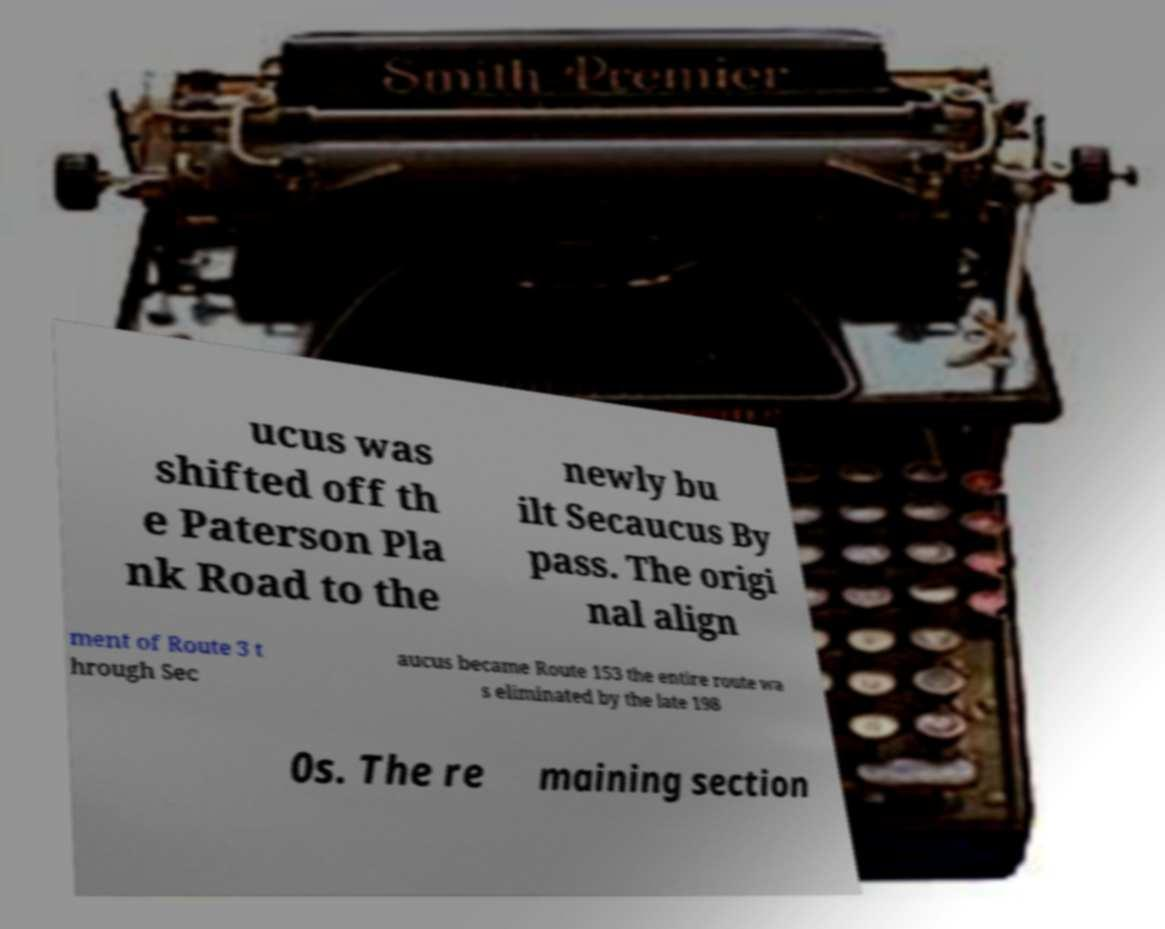I need the written content from this picture converted into text. Can you do that? ucus was shifted off th e Paterson Pla nk Road to the newly bu ilt Secaucus By pass. The origi nal align ment of Route 3 t hrough Sec aucus became Route 153 the entire route wa s eliminated by the late 198 0s. The re maining section 